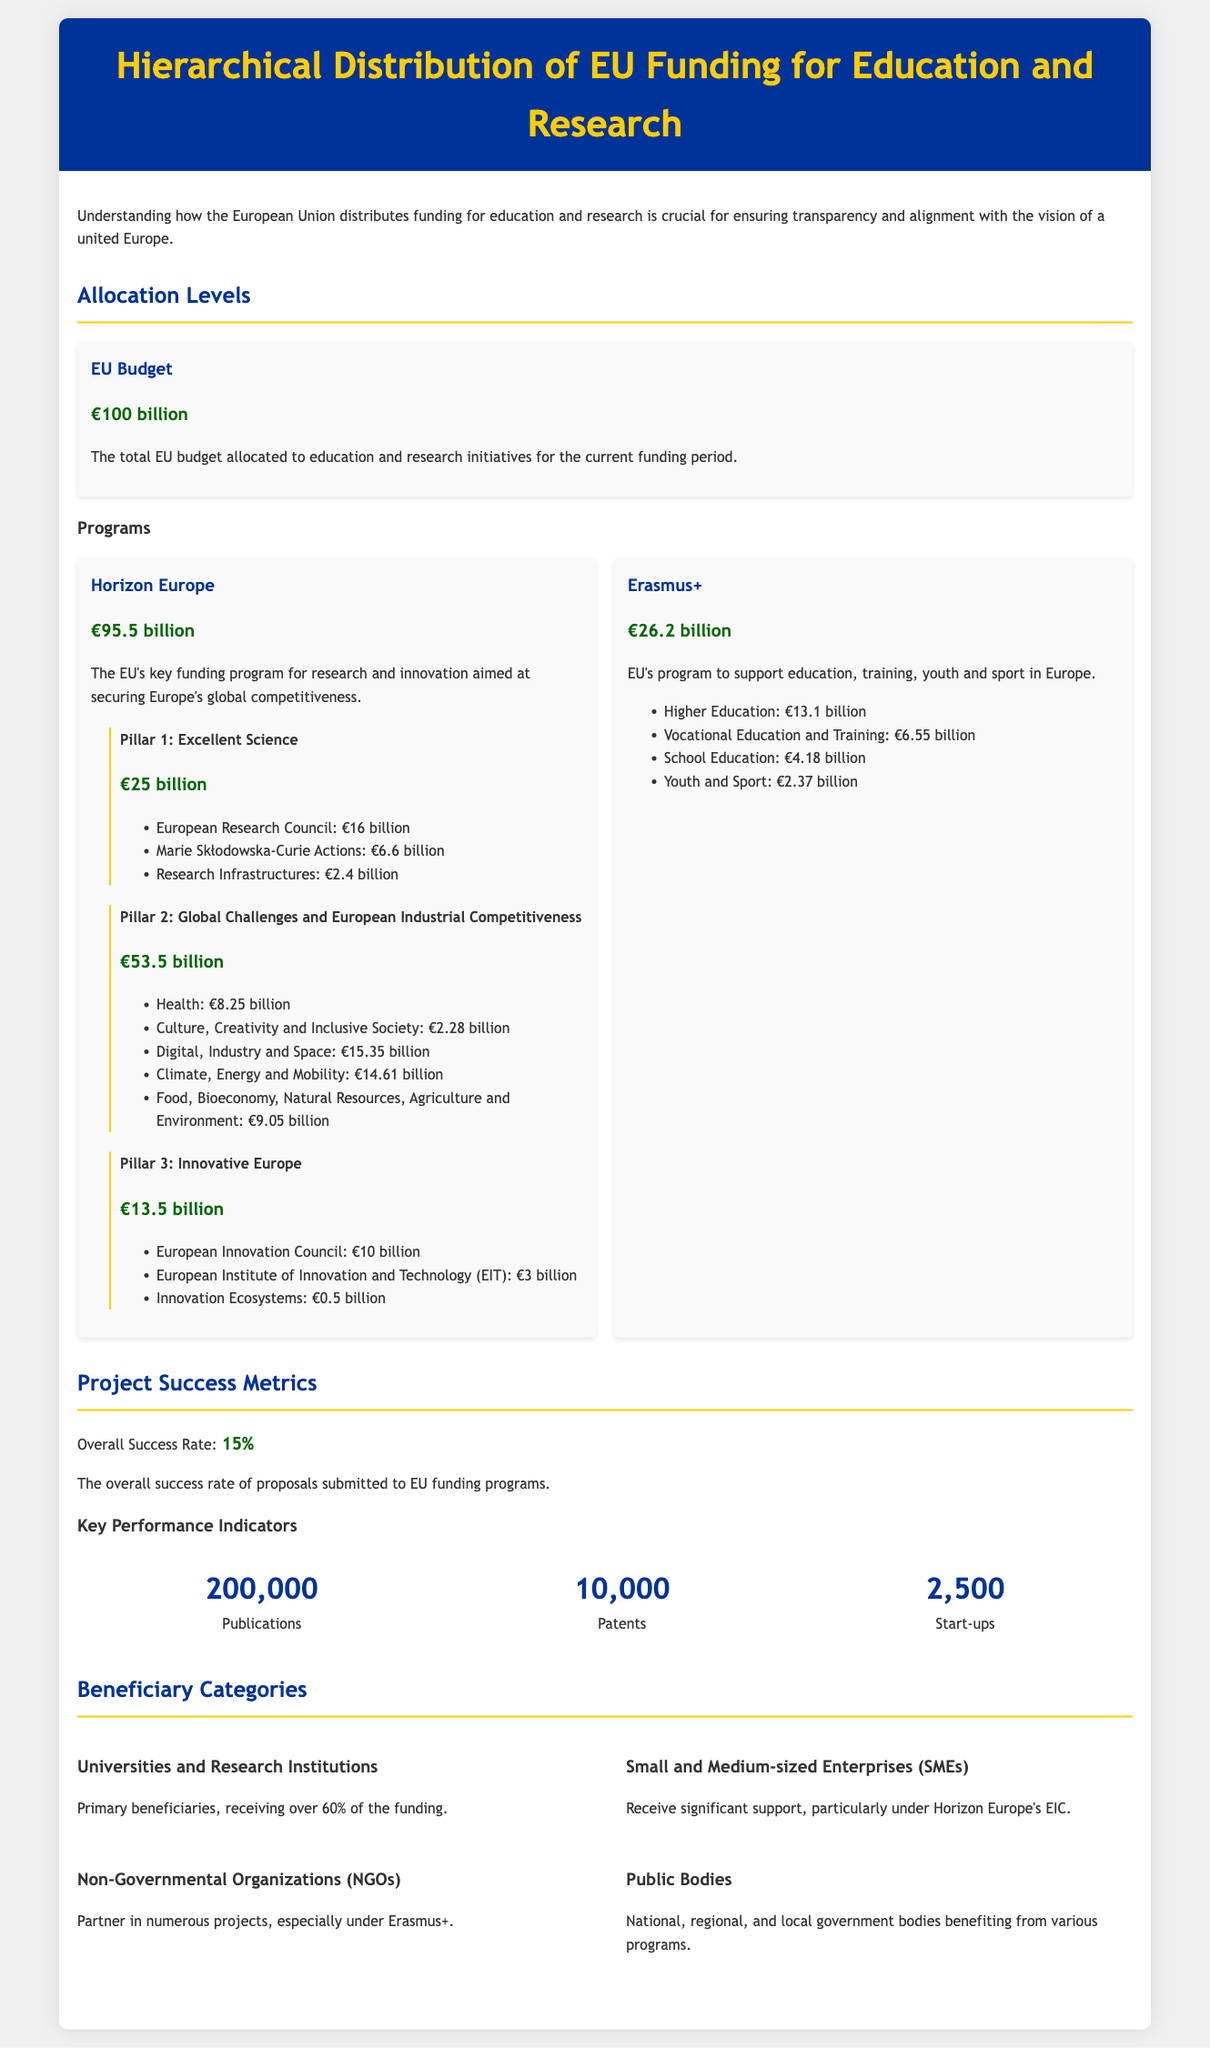What is the total EU budget allocated to education and research? The total EU budget allocated for education and research initiatives is explicitly stated in the document.
Answer: €100 billion How much funding does Horizon Europe receive? Horizon Europe is identified as a key funding program and its allocated funding is mentioned in the document.
Answer: €95.5 billion What is the success rate of proposals submitted to EU funding programs? The overall success rate is highlighted in the section on project success metrics.
Answer: 15% Which pillar of Horizon Europe has the highest allocation? The pillars of Horizon Europe are listed along with their funding amounts, allowing for comparison.
Answer: Pillar 2: Global Challenges and European Industrial Competitiveness How much funding is allocated to the European Research Council? The document breaks down the funding distribution under Pillar 1, allowing for easy retrieval of specific amounts.
Answer: €16 billion Who are the primary beneficiaries of the EU education and research funding? The section on beneficiary categories outlines the main groups benefiting from the funding.
Answer: Universities and Research Institutions What is the funding amount for Erasmus+? Erasmus+ is specified in the document with its total funding amount.
Answer: €26.2 billion How many patents resulted from the funded projects? The document provides specific metrics representing the output of the funded projects.
Answer: 10,000 What is the funding allocated for Culture, Creativity and Inclusive Society? The funding details are provided under Pillar 2's various categories, including this specific area.
Answer: €2.28 billion 